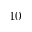Convert formula to latex. <formula><loc_0><loc_0><loc_500><loc_500>1 0</formula> 